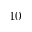Convert formula to latex. <formula><loc_0><loc_0><loc_500><loc_500>1 0</formula> 